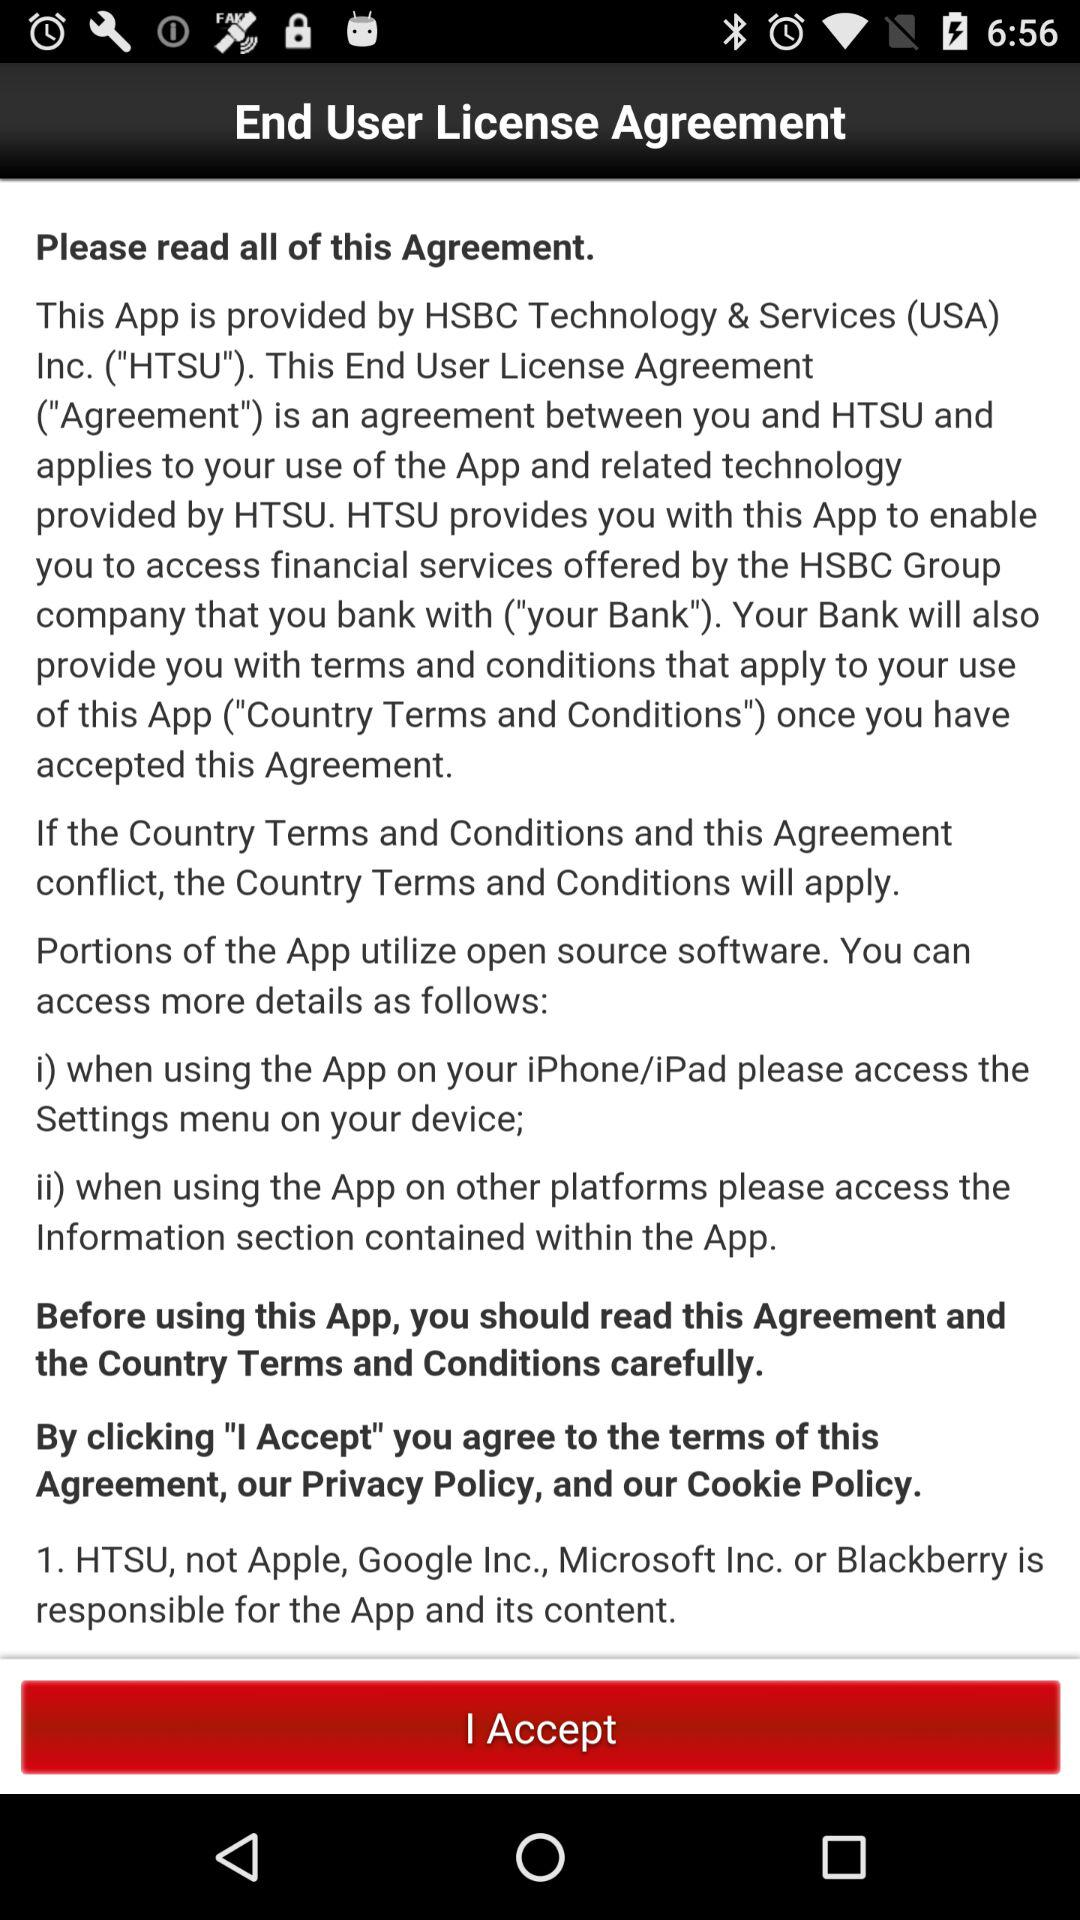Who is the provider of the application? The provider of the application is HSBC Technology & Services (USA) Inc. ("HTSU"). 